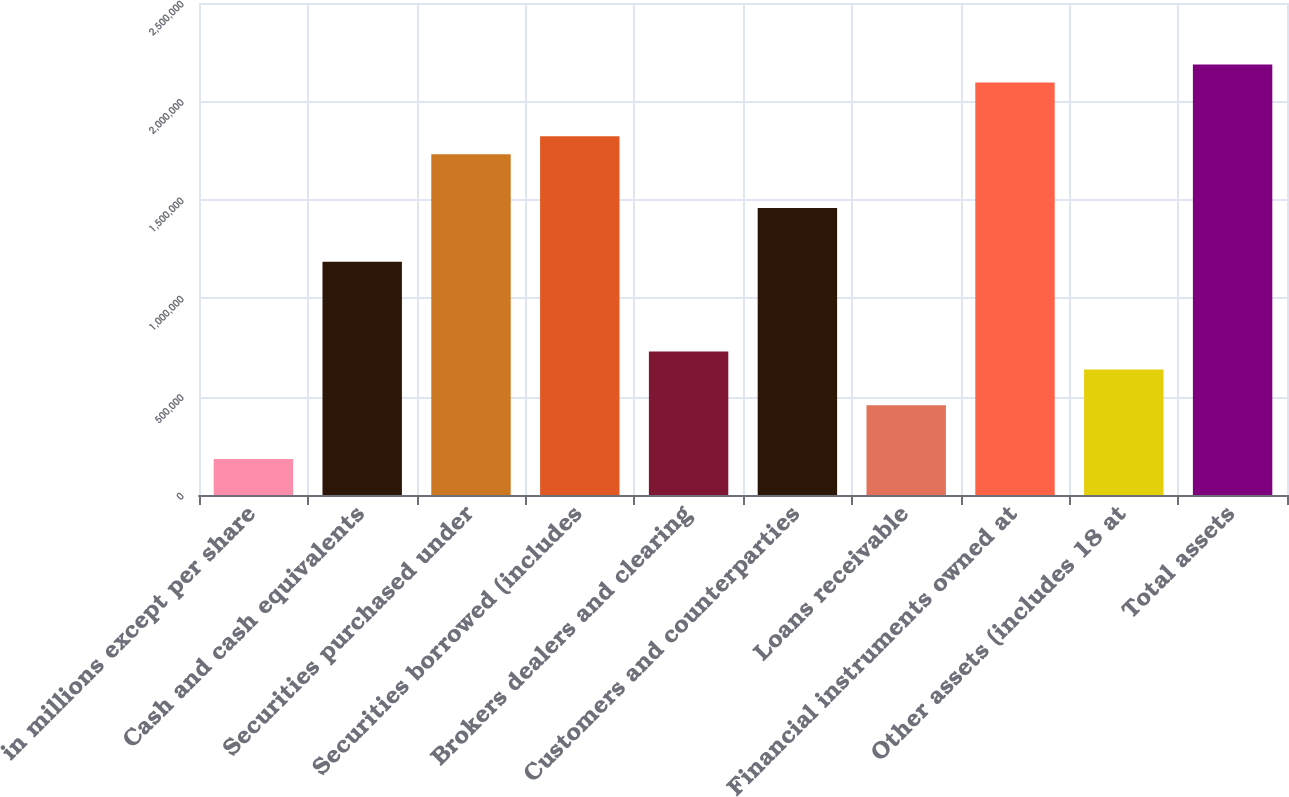Convert chart. <chart><loc_0><loc_0><loc_500><loc_500><bar_chart><fcel>in millions except per share<fcel>Cash and cash equivalents<fcel>Securities purchased under<fcel>Securities borrowed (includes<fcel>Brokers dealers and clearing<fcel>Customers and counterparties<fcel>Loans receivable<fcel>Financial instruments owned at<fcel>Other assets (includes 18 at<fcel>Total assets<nl><fcel>182308<fcel>1.18496e+06<fcel>1.73186e+06<fcel>1.82301e+06<fcel>729207<fcel>1.45841e+06<fcel>455758<fcel>2.09646e+06<fcel>638057<fcel>2.18761e+06<nl></chart> 